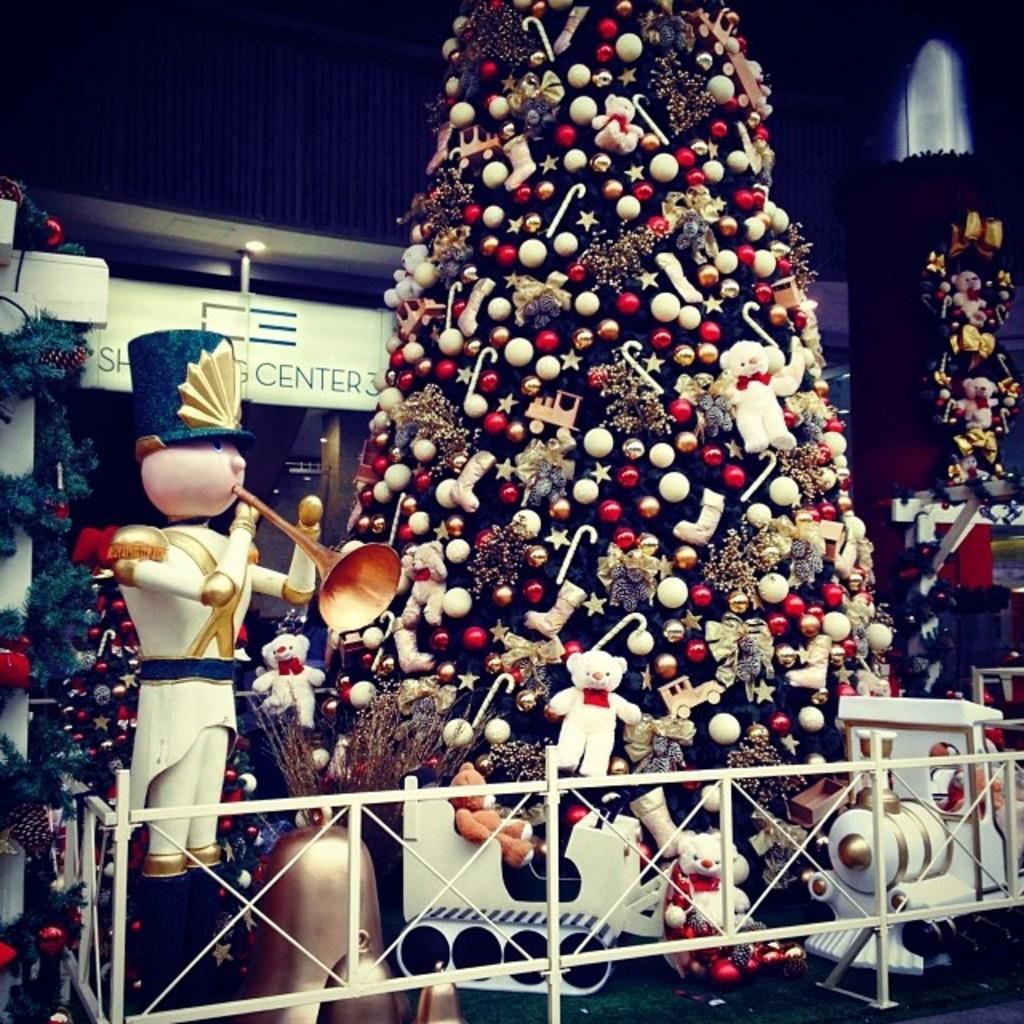In one or two sentences, can you explain what this image depicts? The picture consists of Christmas trees, toys, railing and a toy train. In the background there are lights and wall. 